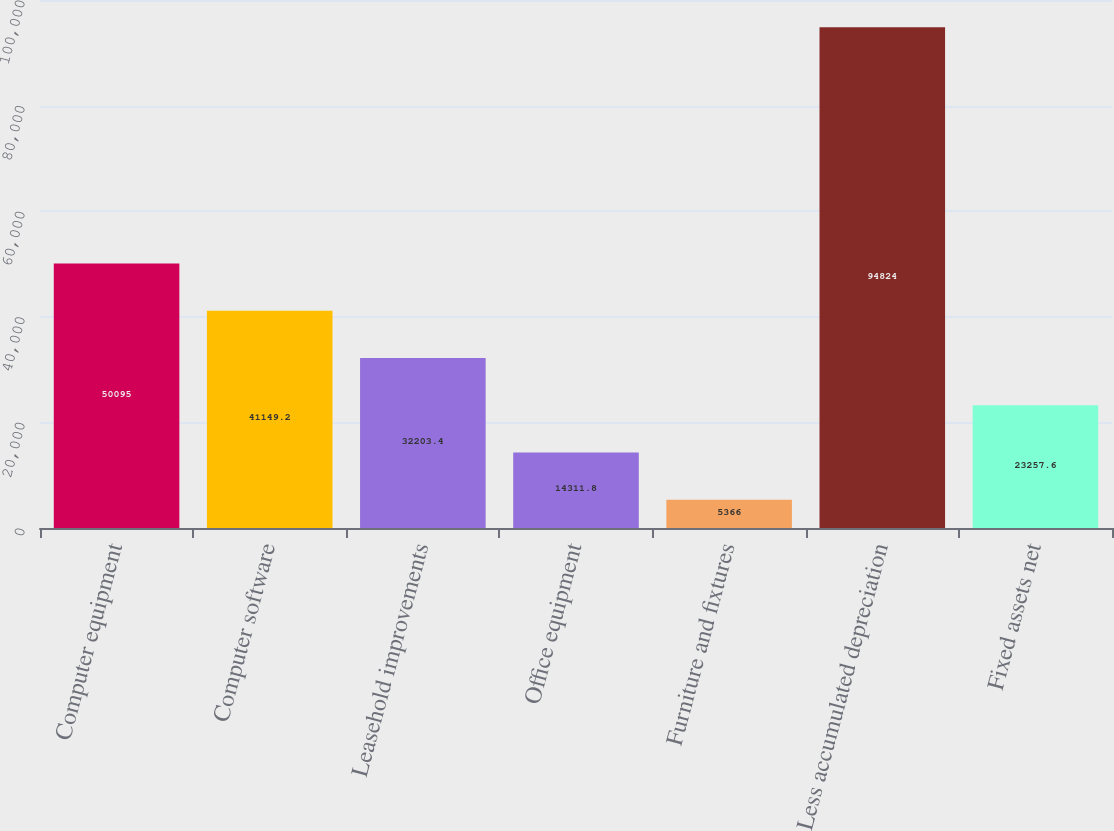Convert chart. <chart><loc_0><loc_0><loc_500><loc_500><bar_chart><fcel>Computer equipment<fcel>Computer software<fcel>Leasehold improvements<fcel>Office equipment<fcel>Furniture and fixtures<fcel>Less accumulated depreciation<fcel>Fixed assets net<nl><fcel>50095<fcel>41149.2<fcel>32203.4<fcel>14311.8<fcel>5366<fcel>94824<fcel>23257.6<nl></chart> 